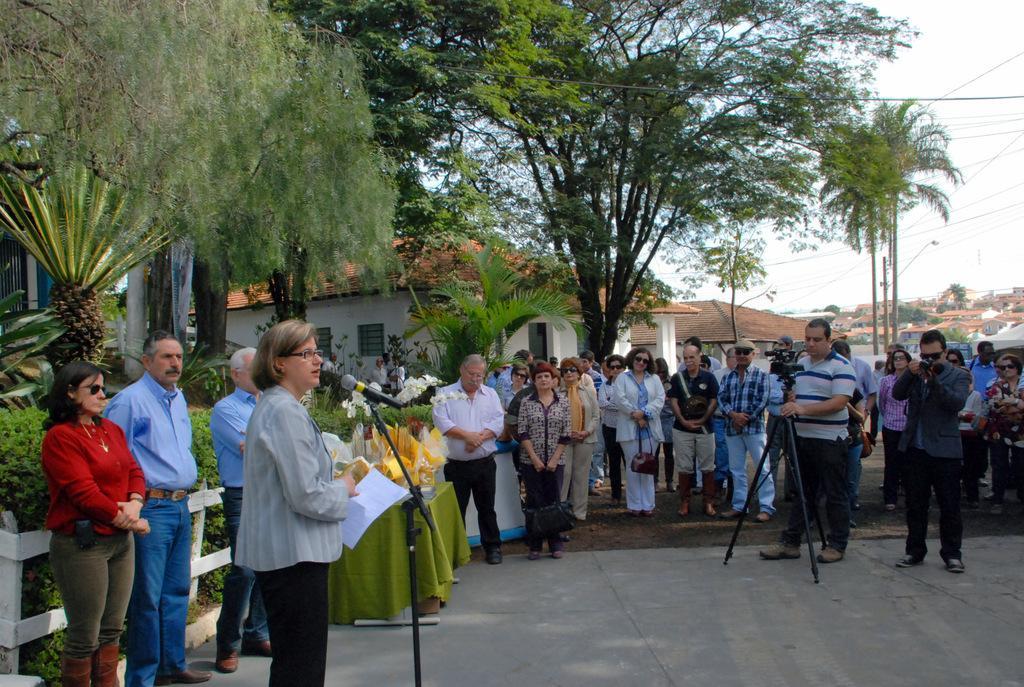Please provide a concise description of this image. On the left side of the image there is a lady standing and holding papers in her hand. In front of her there is a stand with mic. And on the left side corner of the image there is a fencing. Behind the fencing there are bushes and also there are plants and trees. In the image there are many people standing. There are few people with goggles and also there is a stand with a video camera. In the background there are houses with roofs and walls. And also there are wires. 